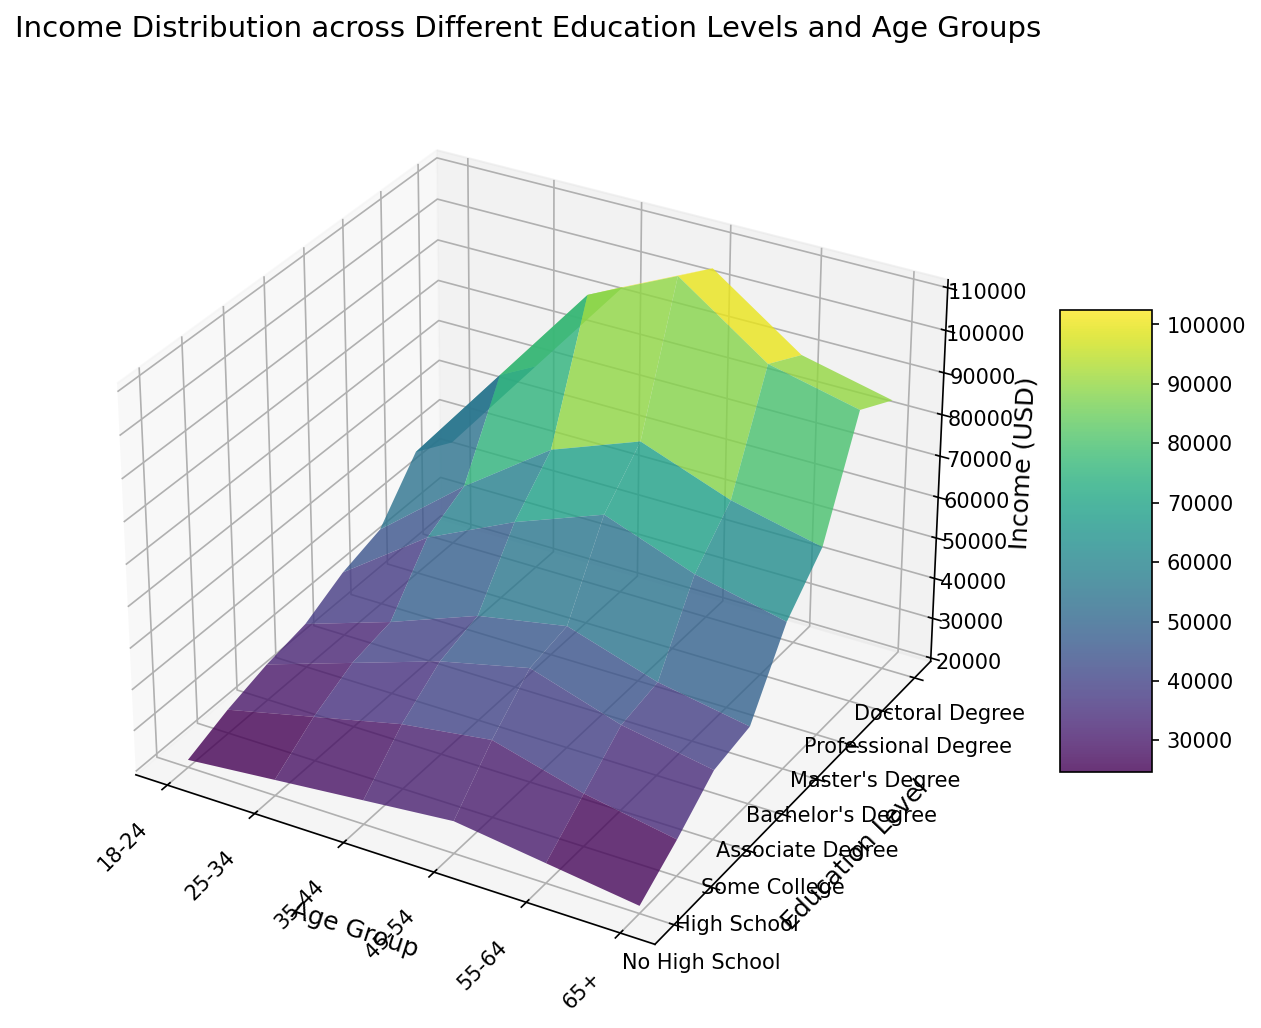Which age group sees the lowest income for individuals with a Bachelor's Degree? Examine the section of the plot corresponding to the Bachelor's Degree education level and compare the income values across all age groups. The lowest vertical height for the Bachelor's Degree series represents the lowest income.
Answer: 18-24 Which education level has the highest income for the 45-54 age group? Locate the section of the plot corresponding to the 45-54 age group and compare the income values across all education levels. The highest vertical height in this series represents the highest income.
Answer: Professional Degree What is the difference in income between the 35-44 and 55-64 age groups for individuals with a Doctoral Degree? Examine the sections of the plot corresponding to the Doctoral Degree education level, specifically for the 35-44 and 55-64 age groups. Calculate the difference between their income values.
Answer: 5000 Which age group generally sees an increase in income with higher education levels? Observe the trends in height within the plot for each age group as the education level increases. Identify which age group shows a consistent upward trend in income as the education levels progress.
Answer: All age groups How does the income for the 65+ age group with a High School education compare to that with a Doctoral Degree? Look at the income values for the 65+ age group for both High School and Doctoral Degree education levels. Compare their vertical heights to determine the difference.
Answer: Lower What is the average income difference between Some College and Master's Degree for individuals aged 25-34? Examine the sections of the plot for Some College and Master's Degree education levels in the 25-34 age group. Calculate the income difference and divide by the number of comparisons (just one in this case).
Answer: 20000 Which education level shows the steepest increase in income between the 18-24 and 25-34 age groups? Identify the vertical differences for each education level between the 18-24 and 25-34 age groups on the plot. The education level with the greatest vertical difference has the steepest increase.
Answer: Doctoral Degree Does any education level show a decrease in income from the 45-54 to 55-64 age group? Analyze the plot to find sections where the income decreases between the 45-54 and 55-64 age groups for each education level. Identify any education levels where this trend occurs.
Answer: High School, Bachelor's Degree, Master's Degree What is the overall trend in income as education level increases for the 35-44 age group? Observe the vertical heights corresponding to the 35-44 age group across all education levels. Determine if there is an upward or downward trend in the height, indicating an increase or decrease in income with higher education levels.
Answer: Increases 